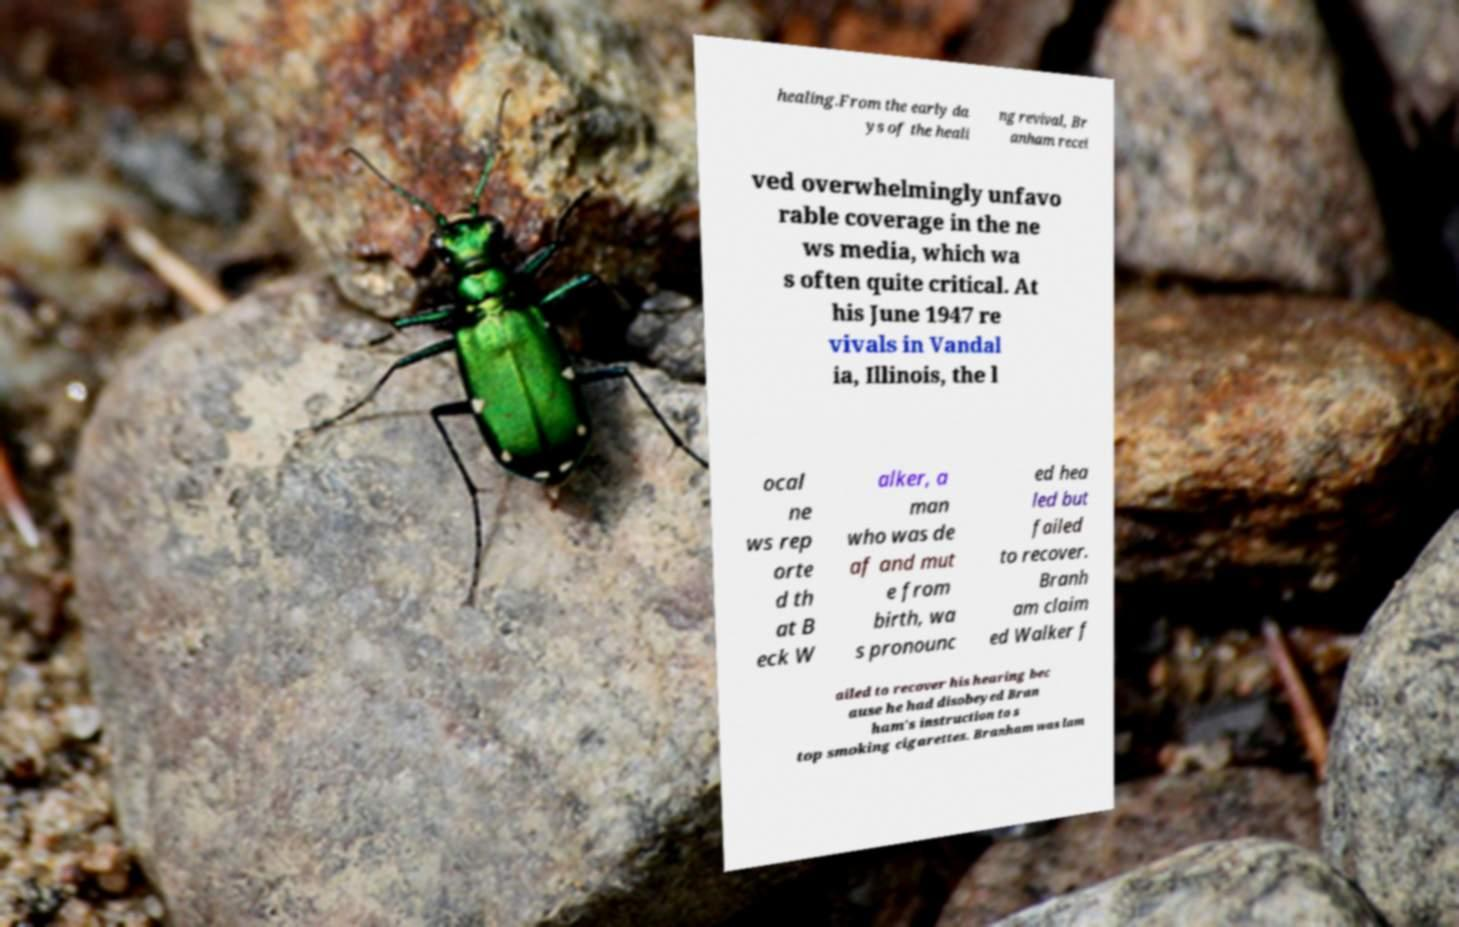Please identify and transcribe the text found in this image. healing.From the early da ys of the heali ng revival, Br anham recei ved overwhelmingly unfavo rable coverage in the ne ws media, which wa s often quite critical. At his June 1947 re vivals in Vandal ia, Illinois, the l ocal ne ws rep orte d th at B eck W alker, a man who was de af and mut e from birth, wa s pronounc ed hea led but failed to recover. Branh am claim ed Walker f ailed to recover his hearing bec ause he had disobeyed Bran ham's instruction to s top smoking cigarettes. Branham was lam 